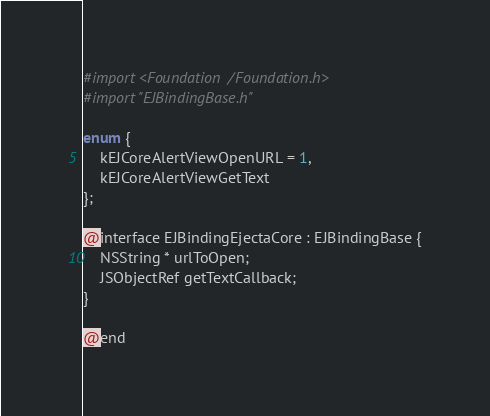<code> <loc_0><loc_0><loc_500><loc_500><_C_>#import <Foundation/Foundation.h>
#import "EJBindingBase.h"

enum {
	kEJCoreAlertViewOpenURL = 1,
	kEJCoreAlertViewGetText
};

@interface EJBindingEjectaCore : EJBindingBase {
	NSString * urlToOpen;
	JSObjectRef getTextCallback;
}

@end
</code> 